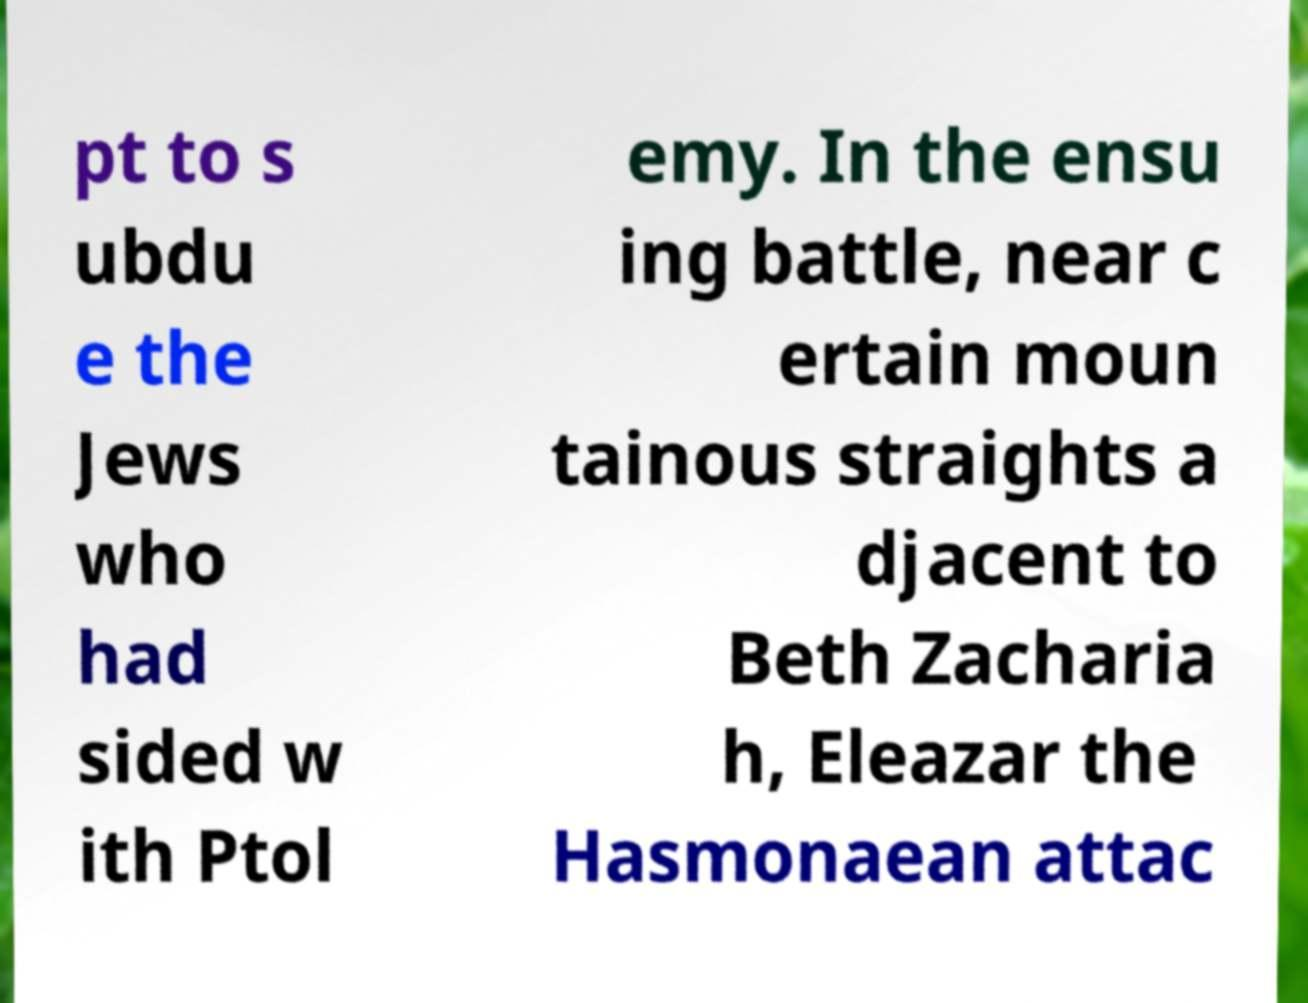Can you accurately transcribe the text from the provided image for me? pt to s ubdu e the Jews who had sided w ith Ptol emy. In the ensu ing battle, near c ertain moun tainous straights a djacent to Beth Zacharia h, Eleazar the Hasmonaean attac 